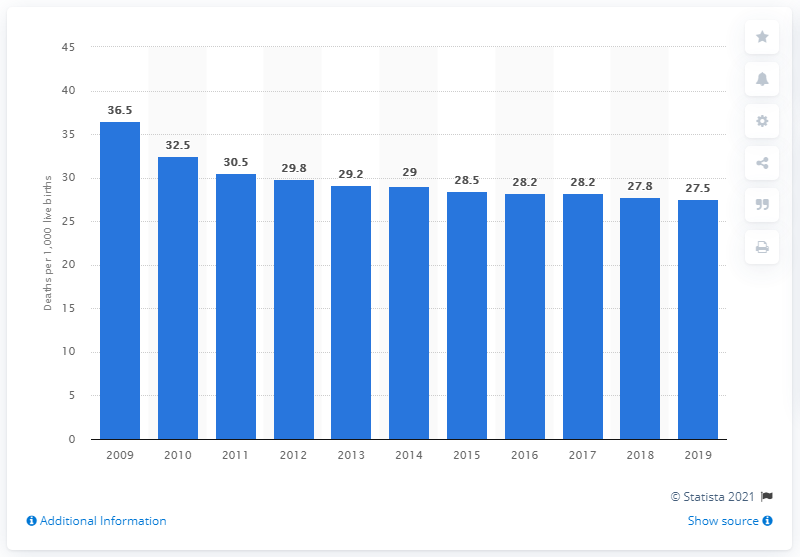Identify some key points in this picture. The infant mortality rate in South Africa in 2019 was 27.5 deaths per 1,000 live births, according to recent data. 